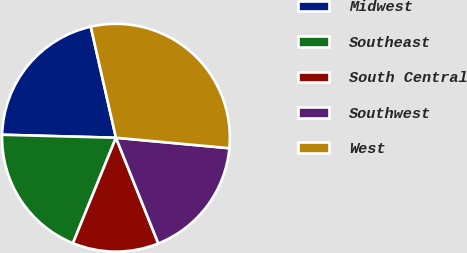Convert chart to OTSL. <chart><loc_0><loc_0><loc_500><loc_500><pie_chart><fcel>Midwest<fcel>Southeast<fcel>South Central<fcel>Southwest<fcel>West<nl><fcel>21.03%<fcel>19.25%<fcel>12.23%<fcel>17.47%<fcel>30.01%<nl></chart> 